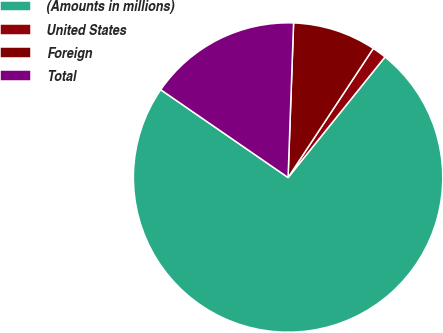Convert chart to OTSL. <chart><loc_0><loc_0><loc_500><loc_500><pie_chart><fcel>(Amounts in millions)<fcel>United States<fcel>Foreign<fcel>Total<nl><fcel>73.83%<fcel>1.49%<fcel>8.72%<fcel>15.96%<nl></chart> 